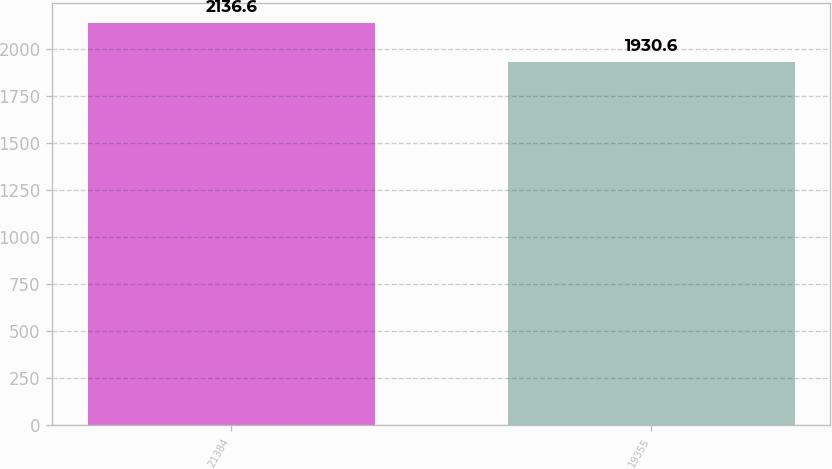<chart> <loc_0><loc_0><loc_500><loc_500><bar_chart><fcel>21384<fcel>19355<nl><fcel>2136.6<fcel>1930.6<nl></chart> 